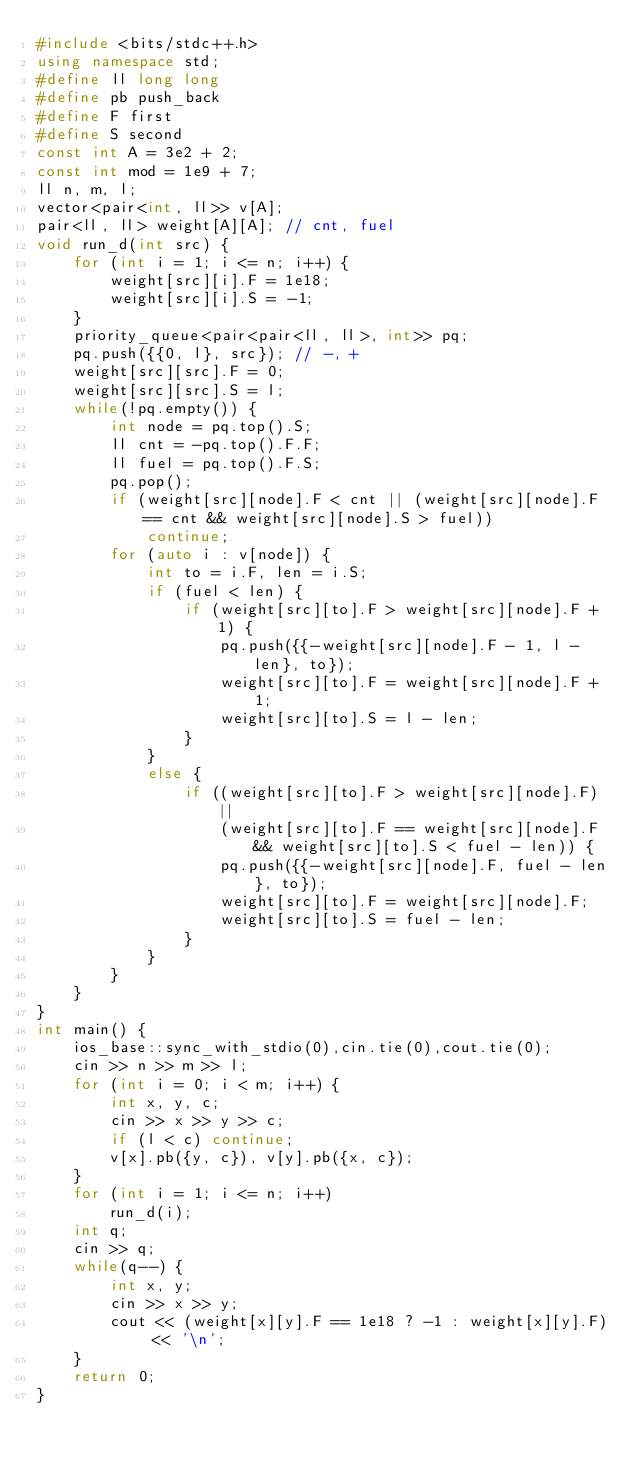<code> <loc_0><loc_0><loc_500><loc_500><_C++_>#include <bits/stdc++.h>
using namespace std;
#define ll long long
#define pb push_back
#define F first
#define S second
const int A = 3e2 + 2;
const int mod = 1e9 + 7;
ll n, m, l;
vector<pair<int, ll>> v[A];
pair<ll, ll> weight[A][A]; // cnt, fuel
void run_d(int src) {
    for (int i = 1; i <= n; i++) {
        weight[src][i].F = 1e18;
        weight[src][i].S = -1;
    }
    priority_queue<pair<pair<ll, ll>, int>> pq;
    pq.push({{0, l}, src}); // -, +
    weight[src][src].F = 0;
    weight[src][src].S = l;
    while(!pq.empty()) {
        int node = pq.top().S;
        ll cnt = -pq.top().F.F;
        ll fuel = pq.top().F.S;
        pq.pop();
        if (weight[src][node].F < cnt || (weight[src][node].F == cnt && weight[src][node].S > fuel))
            continue;
        for (auto i : v[node]) {
            int to = i.F, len = i.S;
            if (fuel < len) {
                if (weight[src][to].F > weight[src][node].F + 1) {
                    pq.push({{-weight[src][node].F - 1, l - len}, to});
                    weight[src][to].F = weight[src][node].F + 1;
                    weight[src][to].S = l - len;
                }
            }
            else {
                if ((weight[src][to].F > weight[src][node].F) ||
                    (weight[src][to].F == weight[src][node].F && weight[src][to].S < fuel - len)) {
                    pq.push({{-weight[src][node].F, fuel - len}, to});
                    weight[src][to].F = weight[src][node].F;
                    weight[src][to].S = fuel - len;
                }
            }
        }
    }
}
int main() {
    ios_base::sync_with_stdio(0),cin.tie(0),cout.tie(0);
    cin >> n >> m >> l;
    for (int i = 0; i < m; i++) {
        int x, y, c;
        cin >> x >> y >> c;
        if (l < c) continue;
        v[x].pb({y, c}), v[y].pb({x, c});
    }
    for (int i = 1; i <= n; i++)
        run_d(i);
    int q;
    cin >> q;
    while(q--) {
        int x, y;
        cin >> x >> y;
        cout << (weight[x][y].F == 1e18 ? -1 : weight[x][y].F) << '\n';
    }
    return 0;
}
</code> 